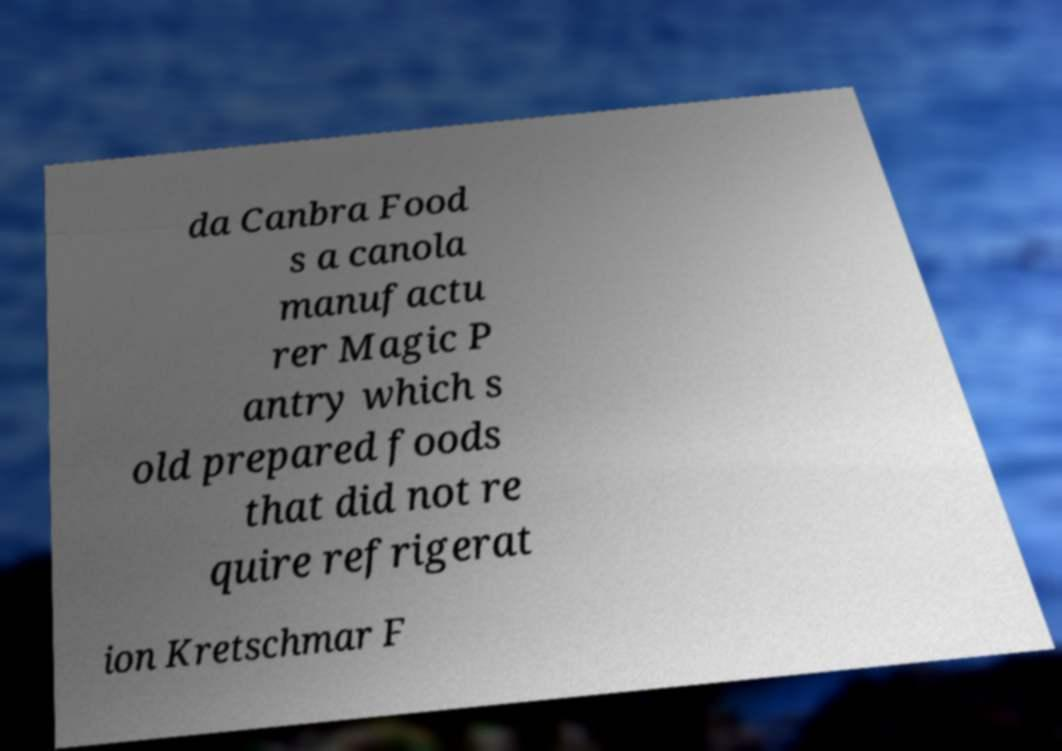Please identify and transcribe the text found in this image. da Canbra Food s a canola manufactu rer Magic P antry which s old prepared foods that did not re quire refrigerat ion Kretschmar F 